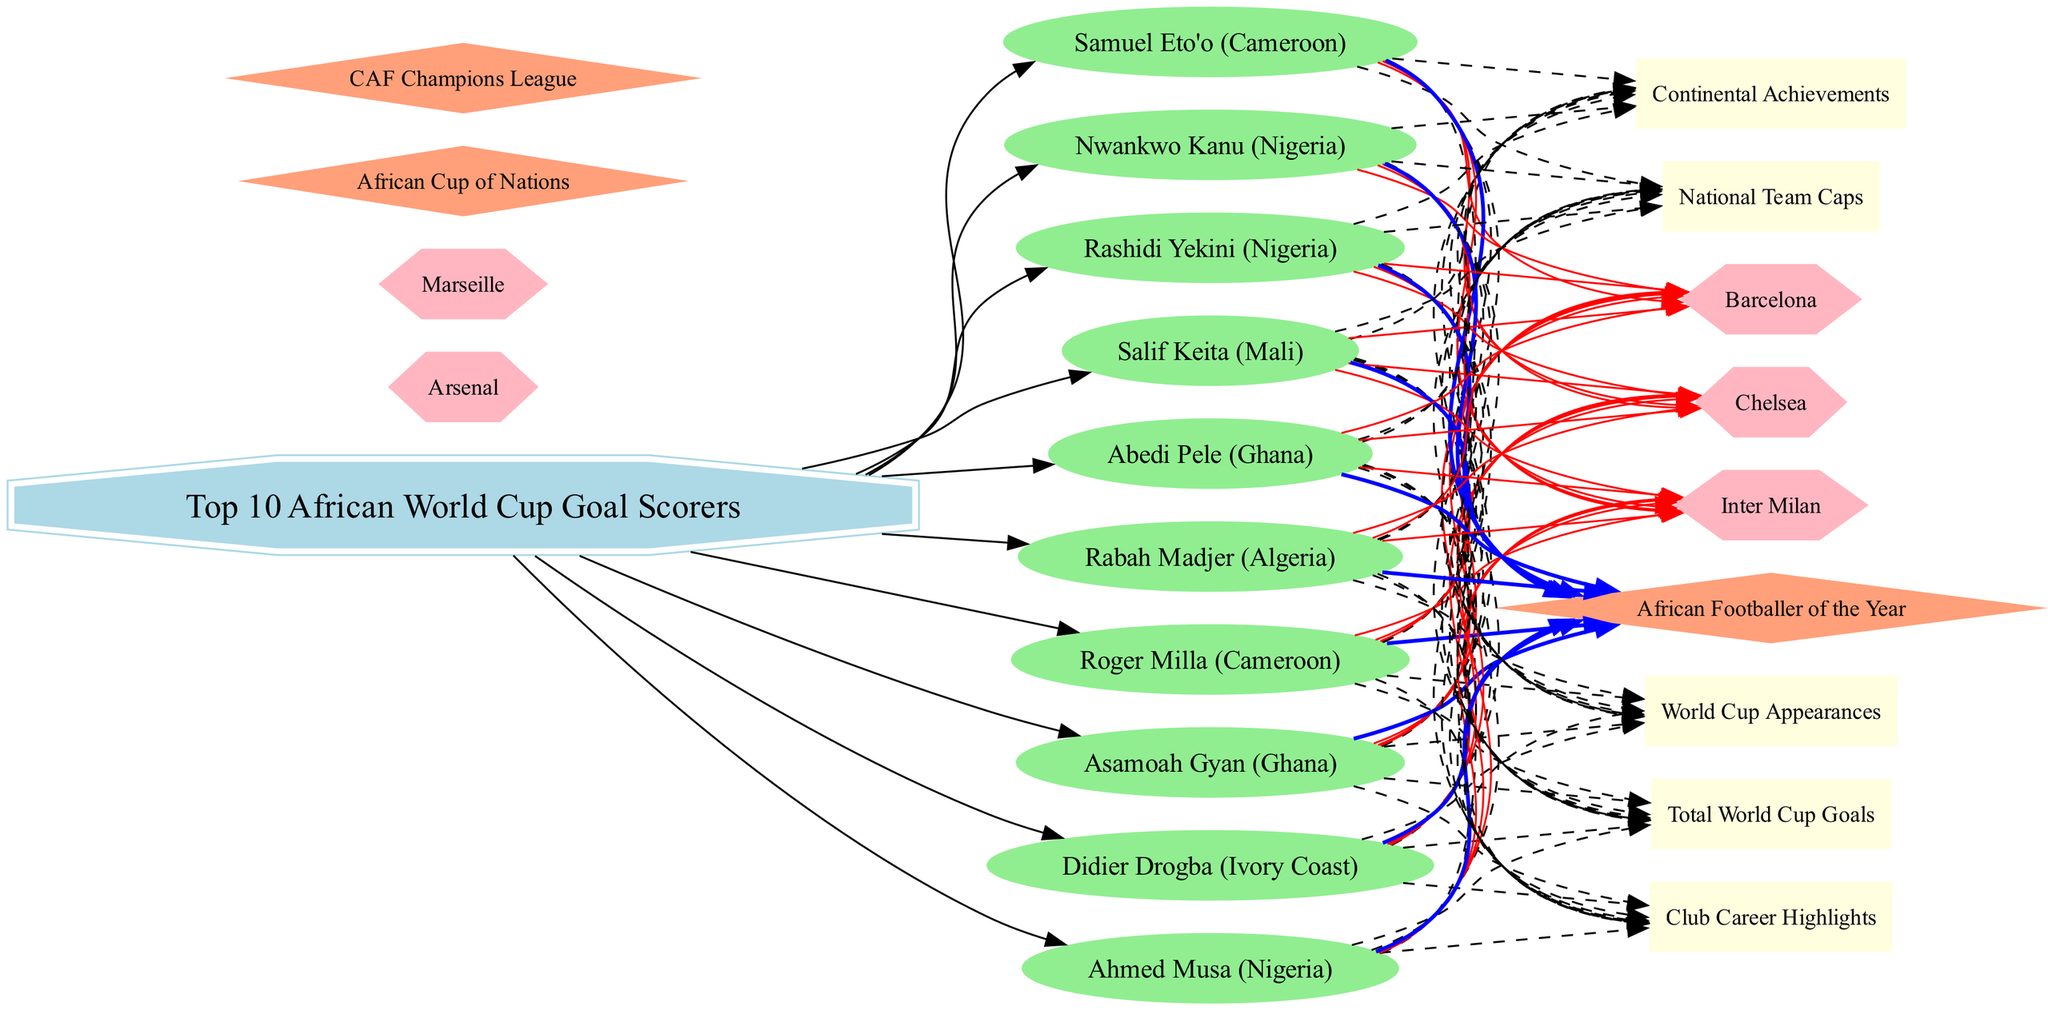What is the center node of the diagram? The center node is labeled as "Top 10 African World Cup Goal Scorers," which is the main focus of the diagram.
Answer: Top 10 African World Cup Goal Scorers How many players are represented in the diagram? Counting the player nodes connected to the center node reveals a total of 10 players depicted in the diagram.
Answer: 10 Which player has connections to the club "Barcelona"? By observing the connections stemming from the player nodes, Roger Milla has a direct dashed edge leading to the club "Barcelona."
Answer: Roger Milla What career milestone is connected to the most players? Examining the dashed edges leading from players to career milestones indicates that "Total World Cup Goals" is connected to all players, hence it's the most connected.
Answer: Total World Cup Goals Which notable club has the most players associated with it? The analysis of player connections shows that Chelsea has connections to multiple players, specifically Didier Drogba and others, making it the most represented club.
Answer: Chelsea Which continental achievement is only associated with one player? Checking the connections, "African Footballer of the Year" has a direct link only to Samuel Eto'o, indicating it is an exclusive achievement for this player.
Answer: Samuel Eto'o How many career milestones are depicted in the diagram? Counting the boxes labeled with career milestones, we find there are 5 distinct milestones represented in the diagram.
Answer: 5 Which two players are connected with the "African Cup of Nations"? Investigating the connections to the "African Cup of Nations" shows that both Asamoah Gyan and Samuel Eto'o have ties to this continental achievement.
Answer: Asamoah Gyan, Samuel Eto'o Which player has the most international team caps? The dashed connection to the "National Team Caps" node indicates that Nwankwo Kanu is highlighted as having the highest number of caps among the players.
Answer: Nwankwo Kanu 